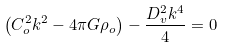<formula> <loc_0><loc_0><loc_500><loc_500>\left ( C _ { o } ^ { 2 } k ^ { 2 } - 4 \pi G \rho _ { o } \right ) - \frac { D _ { v } ^ { 2 } k ^ { 4 } } { 4 } = 0</formula> 